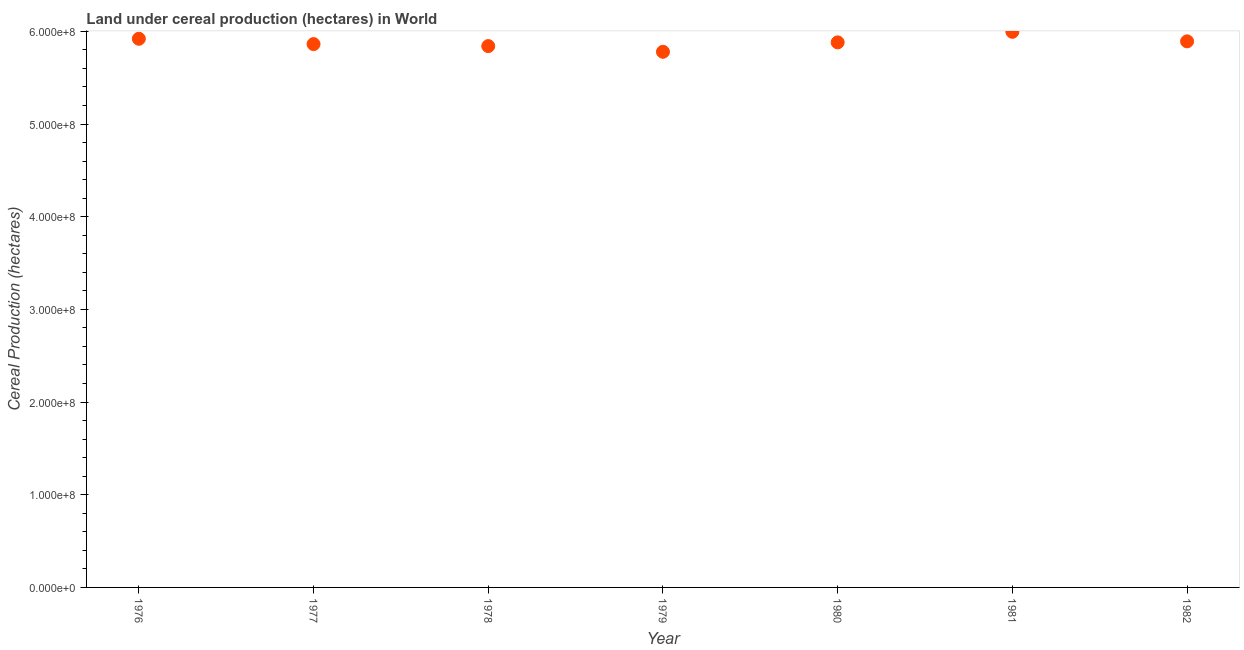What is the land under cereal production in 1981?
Offer a very short reply. 5.99e+08. Across all years, what is the maximum land under cereal production?
Ensure brevity in your answer.  5.99e+08. Across all years, what is the minimum land under cereal production?
Give a very brief answer. 5.78e+08. In which year was the land under cereal production maximum?
Give a very brief answer. 1981. In which year was the land under cereal production minimum?
Give a very brief answer. 1979. What is the sum of the land under cereal production?
Your response must be concise. 4.12e+09. What is the difference between the land under cereal production in 1977 and 1981?
Provide a short and direct response. -1.32e+07. What is the average land under cereal production per year?
Give a very brief answer. 5.88e+08. What is the median land under cereal production?
Offer a very short reply. 5.88e+08. Do a majority of the years between 1978 and 1977 (inclusive) have land under cereal production greater than 360000000 hectares?
Your answer should be very brief. No. What is the ratio of the land under cereal production in 1976 to that in 1981?
Your answer should be very brief. 0.99. What is the difference between the highest and the second highest land under cereal production?
Your answer should be compact. 7.49e+06. Is the sum of the land under cereal production in 1976 and 1980 greater than the maximum land under cereal production across all years?
Your answer should be very brief. Yes. What is the difference between the highest and the lowest land under cereal production?
Make the answer very short. 2.15e+07. In how many years, is the land under cereal production greater than the average land under cereal production taken over all years?
Offer a very short reply. 3. How many dotlines are there?
Your response must be concise. 1. What is the difference between two consecutive major ticks on the Y-axis?
Provide a short and direct response. 1.00e+08. Are the values on the major ticks of Y-axis written in scientific E-notation?
Your answer should be very brief. Yes. Does the graph contain any zero values?
Keep it short and to the point. No. What is the title of the graph?
Ensure brevity in your answer.  Land under cereal production (hectares) in World. What is the label or title of the X-axis?
Provide a short and direct response. Year. What is the label or title of the Y-axis?
Keep it short and to the point. Cereal Production (hectares). What is the Cereal Production (hectares) in 1976?
Your response must be concise. 5.92e+08. What is the Cereal Production (hectares) in 1977?
Offer a terse response. 5.86e+08. What is the Cereal Production (hectares) in 1978?
Ensure brevity in your answer.  5.84e+08. What is the Cereal Production (hectares) in 1979?
Keep it short and to the point. 5.78e+08. What is the Cereal Production (hectares) in 1980?
Give a very brief answer. 5.88e+08. What is the Cereal Production (hectares) in 1981?
Your answer should be compact. 5.99e+08. What is the Cereal Production (hectares) in 1982?
Provide a succinct answer. 5.89e+08. What is the difference between the Cereal Production (hectares) in 1976 and 1977?
Your answer should be very brief. 5.74e+06. What is the difference between the Cereal Production (hectares) in 1976 and 1978?
Make the answer very short. 7.91e+06. What is the difference between the Cereal Production (hectares) in 1976 and 1979?
Your answer should be very brief. 1.40e+07. What is the difference between the Cereal Production (hectares) in 1976 and 1980?
Your answer should be very brief. 3.88e+06. What is the difference between the Cereal Production (hectares) in 1976 and 1981?
Ensure brevity in your answer.  -7.49e+06. What is the difference between the Cereal Production (hectares) in 1976 and 1982?
Your answer should be very brief. 2.78e+06. What is the difference between the Cereal Production (hectares) in 1977 and 1978?
Provide a short and direct response. 2.17e+06. What is the difference between the Cereal Production (hectares) in 1977 and 1979?
Provide a short and direct response. 8.31e+06. What is the difference between the Cereal Production (hectares) in 1977 and 1980?
Your answer should be very brief. -1.86e+06. What is the difference between the Cereal Production (hectares) in 1977 and 1981?
Offer a terse response. -1.32e+07. What is the difference between the Cereal Production (hectares) in 1977 and 1982?
Ensure brevity in your answer.  -2.96e+06. What is the difference between the Cereal Production (hectares) in 1978 and 1979?
Your answer should be very brief. 6.14e+06. What is the difference between the Cereal Production (hectares) in 1978 and 1980?
Your answer should be compact. -4.03e+06. What is the difference between the Cereal Production (hectares) in 1978 and 1981?
Your answer should be very brief. -1.54e+07. What is the difference between the Cereal Production (hectares) in 1978 and 1982?
Your response must be concise. -5.13e+06. What is the difference between the Cereal Production (hectares) in 1979 and 1980?
Give a very brief answer. -1.02e+07. What is the difference between the Cereal Production (hectares) in 1979 and 1981?
Provide a short and direct response. -2.15e+07. What is the difference between the Cereal Production (hectares) in 1979 and 1982?
Make the answer very short. -1.13e+07. What is the difference between the Cereal Production (hectares) in 1980 and 1981?
Your answer should be compact. -1.14e+07. What is the difference between the Cereal Production (hectares) in 1980 and 1982?
Make the answer very short. -1.10e+06. What is the difference between the Cereal Production (hectares) in 1981 and 1982?
Give a very brief answer. 1.03e+07. What is the ratio of the Cereal Production (hectares) in 1976 to that in 1980?
Your response must be concise. 1.01. What is the ratio of the Cereal Production (hectares) in 1976 to that in 1981?
Provide a succinct answer. 0.99. What is the ratio of the Cereal Production (hectares) in 1977 to that in 1980?
Provide a short and direct response. 1. What is the ratio of the Cereal Production (hectares) in 1977 to that in 1982?
Offer a terse response. 0.99. What is the ratio of the Cereal Production (hectares) in 1978 to that in 1979?
Your answer should be very brief. 1.01. What is the ratio of the Cereal Production (hectares) in 1978 to that in 1982?
Provide a succinct answer. 0.99. What is the ratio of the Cereal Production (hectares) in 1979 to that in 1982?
Make the answer very short. 0.98. What is the ratio of the Cereal Production (hectares) in 1980 to that in 1981?
Offer a terse response. 0.98. 